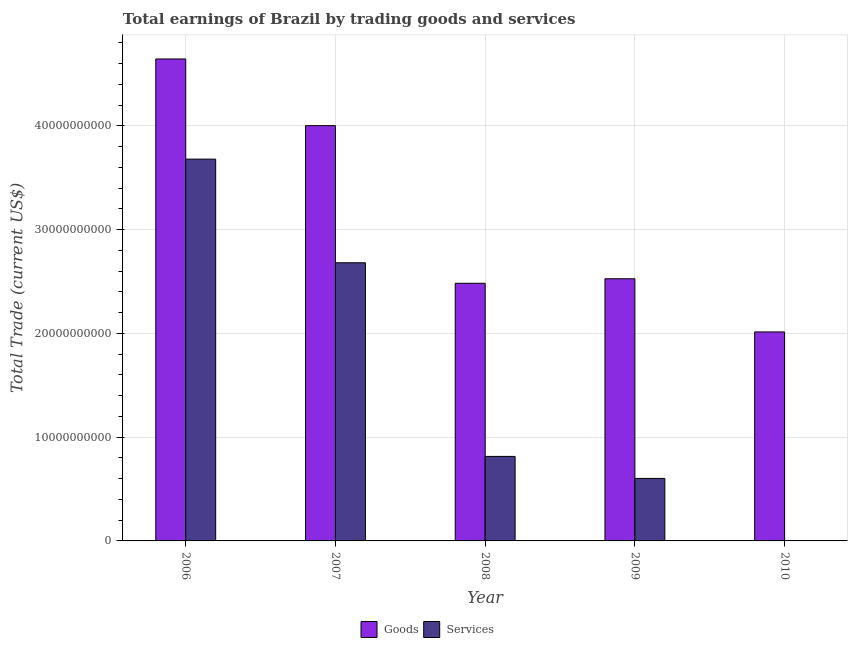How many different coloured bars are there?
Offer a terse response. 2. What is the label of the 3rd group of bars from the left?
Your answer should be compact. 2008. What is the amount earned by trading services in 2007?
Provide a short and direct response. 2.68e+1. Across all years, what is the maximum amount earned by trading services?
Keep it short and to the point. 3.68e+1. Across all years, what is the minimum amount earned by trading services?
Provide a short and direct response. 0. What is the total amount earned by trading goods in the graph?
Ensure brevity in your answer.  1.57e+11. What is the difference between the amount earned by trading goods in 2006 and that in 2009?
Ensure brevity in your answer.  2.12e+1. What is the difference between the amount earned by trading services in 2008 and the amount earned by trading goods in 2009?
Make the answer very short. 2.12e+09. What is the average amount earned by trading services per year?
Your response must be concise. 1.56e+1. In the year 2007, what is the difference between the amount earned by trading services and amount earned by trading goods?
Your answer should be compact. 0. What is the ratio of the amount earned by trading services in 2006 to that in 2007?
Provide a succinct answer. 1.37. Is the amount earned by trading services in 2006 less than that in 2007?
Provide a short and direct response. No. Is the difference between the amount earned by trading goods in 2007 and 2008 greater than the difference between the amount earned by trading services in 2007 and 2008?
Your answer should be compact. No. What is the difference between the highest and the second highest amount earned by trading services?
Provide a short and direct response. 9.99e+09. What is the difference between the highest and the lowest amount earned by trading services?
Provide a succinct answer. 3.68e+1. How many bars are there?
Your response must be concise. 9. Are all the bars in the graph horizontal?
Offer a very short reply. No. What is the difference between two consecutive major ticks on the Y-axis?
Keep it short and to the point. 1.00e+1. Are the values on the major ticks of Y-axis written in scientific E-notation?
Provide a short and direct response. No. How many legend labels are there?
Provide a succinct answer. 2. How are the legend labels stacked?
Keep it short and to the point. Horizontal. What is the title of the graph?
Provide a succinct answer. Total earnings of Brazil by trading goods and services. What is the label or title of the X-axis?
Make the answer very short. Year. What is the label or title of the Y-axis?
Your answer should be very brief. Total Trade (current US$). What is the Total Trade (current US$) of Goods in 2006?
Your response must be concise. 4.65e+1. What is the Total Trade (current US$) of Services in 2006?
Make the answer very short. 3.68e+1. What is the Total Trade (current US$) of Goods in 2007?
Your response must be concise. 4.00e+1. What is the Total Trade (current US$) of Services in 2007?
Keep it short and to the point. 2.68e+1. What is the Total Trade (current US$) in Goods in 2008?
Provide a short and direct response. 2.48e+1. What is the Total Trade (current US$) in Services in 2008?
Make the answer very short. 8.15e+09. What is the Total Trade (current US$) of Goods in 2009?
Give a very brief answer. 2.53e+1. What is the Total Trade (current US$) of Services in 2009?
Provide a short and direct response. 6.03e+09. What is the Total Trade (current US$) of Goods in 2010?
Ensure brevity in your answer.  2.01e+1. Across all years, what is the maximum Total Trade (current US$) of Goods?
Provide a succinct answer. 4.65e+1. Across all years, what is the maximum Total Trade (current US$) of Services?
Provide a succinct answer. 3.68e+1. Across all years, what is the minimum Total Trade (current US$) in Goods?
Provide a short and direct response. 2.01e+1. Across all years, what is the minimum Total Trade (current US$) of Services?
Offer a very short reply. 0. What is the total Total Trade (current US$) in Goods in the graph?
Your response must be concise. 1.57e+11. What is the total Total Trade (current US$) in Services in the graph?
Your answer should be very brief. 7.78e+1. What is the difference between the Total Trade (current US$) of Goods in 2006 and that in 2007?
Ensure brevity in your answer.  6.43e+09. What is the difference between the Total Trade (current US$) of Services in 2006 and that in 2007?
Offer a terse response. 9.99e+09. What is the difference between the Total Trade (current US$) in Goods in 2006 and that in 2008?
Ensure brevity in your answer.  2.16e+1. What is the difference between the Total Trade (current US$) in Services in 2006 and that in 2008?
Give a very brief answer. 2.87e+1. What is the difference between the Total Trade (current US$) in Goods in 2006 and that in 2009?
Keep it short and to the point. 2.12e+1. What is the difference between the Total Trade (current US$) in Services in 2006 and that in 2009?
Ensure brevity in your answer.  3.08e+1. What is the difference between the Total Trade (current US$) of Goods in 2006 and that in 2010?
Provide a short and direct response. 2.63e+1. What is the difference between the Total Trade (current US$) of Goods in 2007 and that in 2008?
Ensure brevity in your answer.  1.52e+1. What is the difference between the Total Trade (current US$) of Services in 2007 and that in 2008?
Provide a short and direct response. 1.87e+1. What is the difference between the Total Trade (current US$) of Goods in 2007 and that in 2009?
Provide a short and direct response. 1.48e+1. What is the difference between the Total Trade (current US$) of Services in 2007 and that in 2009?
Keep it short and to the point. 2.08e+1. What is the difference between the Total Trade (current US$) in Goods in 2007 and that in 2010?
Ensure brevity in your answer.  1.99e+1. What is the difference between the Total Trade (current US$) in Goods in 2008 and that in 2009?
Provide a short and direct response. -4.36e+08. What is the difference between the Total Trade (current US$) of Services in 2008 and that in 2009?
Offer a very short reply. 2.12e+09. What is the difference between the Total Trade (current US$) of Goods in 2008 and that in 2010?
Make the answer very short. 4.69e+09. What is the difference between the Total Trade (current US$) of Goods in 2009 and that in 2010?
Give a very brief answer. 5.12e+09. What is the difference between the Total Trade (current US$) in Goods in 2006 and the Total Trade (current US$) in Services in 2007?
Make the answer very short. 1.96e+1. What is the difference between the Total Trade (current US$) of Goods in 2006 and the Total Trade (current US$) of Services in 2008?
Your answer should be very brief. 3.83e+1. What is the difference between the Total Trade (current US$) of Goods in 2006 and the Total Trade (current US$) of Services in 2009?
Give a very brief answer. 4.04e+1. What is the difference between the Total Trade (current US$) in Goods in 2007 and the Total Trade (current US$) in Services in 2008?
Make the answer very short. 3.19e+1. What is the difference between the Total Trade (current US$) in Goods in 2007 and the Total Trade (current US$) in Services in 2009?
Your answer should be compact. 3.40e+1. What is the difference between the Total Trade (current US$) in Goods in 2008 and the Total Trade (current US$) in Services in 2009?
Ensure brevity in your answer.  1.88e+1. What is the average Total Trade (current US$) of Goods per year?
Offer a very short reply. 3.13e+1. What is the average Total Trade (current US$) in Services per year?
Provide a short and direct response. 1.56e+1. In the year 2006, what is the difference between the Total Trade (current US$) in Goods and Total Trade (current US$) in Services?
Your answer should be compact. 9.65e+09. In the year 2007, what is the difference between the Total Trade (current US$) in Goods and Total Trade (current US$) in Services?
Offer a very short reply. 1.32e+1. In the year 2008, what is the difference between the Total Trade (current US$) of Goods and Total Trade (current US$) of Services?
Ensure brevity in your answer.  1.67e+1. In the year 2009, what is the difference between the Total Trade (current US$) of Goods and Total Trade (current US$) of Services?
Your answer should be very brief. 1.92e+1. What is the ratio of the Total Trade (current US$) of Goods in 2006 to that in 2007?
Offer a very short reply. 1.16. What is the ratio of the Total Trade (current US$) of Services in 2006 to that in 2007?
Your response must be concise. 1.37. What is the ratio of the Total Trade (current US$) in Goods in 2006 to that in 2008?
Provide a succinct answer. 1.87. What is the ratio of the Total Trade (current US$) of Services in 2006 to that in 2008?
Offer a terse response. 4.52. What is the ratio of the Total Trade (current US$) in Goods in 2006 to that in 2009?
Your answer should be very brief. 1.84. What is the ratio of the Total Trade (current US$) in Services in 2006 to that in 2009?
Provide a short and direct response. 6.11. What is the ratio of the Total Trade (current US$) of Goods in 2006 to that in 2010?
Provide a short and direct response. 2.31. What is the ratio of the Total Trade (current US$) in Goods in 2007 to that in 2008?
Ensure brevity in your answer.  1.61. What is the ratio of the Total Trade (current US$) in Services in 2007 to that in 2008?
Give a very brief answer. 3.29. What is the ratio of the Total Trade (current US$) in Goods in 2007 to that in 2009?
Your answer should be very brief. 1.58. What is the ratio of the Total Trade (current US$) of Services in 2007 to that in 2009?
Ensure brevity in your answer.  4.45. What is the ratio of the Total Trade (current US$) of Goods in 2007 to that in 2010?
Keep it short and to the point. 1.99. What is the ratio of the Total Trade (current US$) of Goods in 2008 to that in 2009?
Give a very brief answer. 0.98. What is the ratio of the Total Trade (current US$) of Services in 2008 to that in 2009?
Your response must be concise. 1.35. What is the ratio of the Total Trade (current US$) of Goods in 2008 to that in 2010?
Your answer should be compact. 1.23. What is the ratio of the Total Trade (current US$) of Goods in 2009 to that in 2010?
Provide a succinct answer. 1.25. What is the difference between the highest and the second highest Total Trade (current US$) in Goods?
Provide a succinct answer. 6.43e+09. What is the difference between the highest and the second highest Total Trade (current US$) in Services?
Give a very brief answer. 9.99e+09. What is the difference between the highest and the lowest Total Trade (current US$) in Goods?
Offer a very short reply. 2.63e+1. What is the difference between the highest and the lowest Total Trade (current US$) of Services?
Your answer should be very brief. 3.68e+1. 